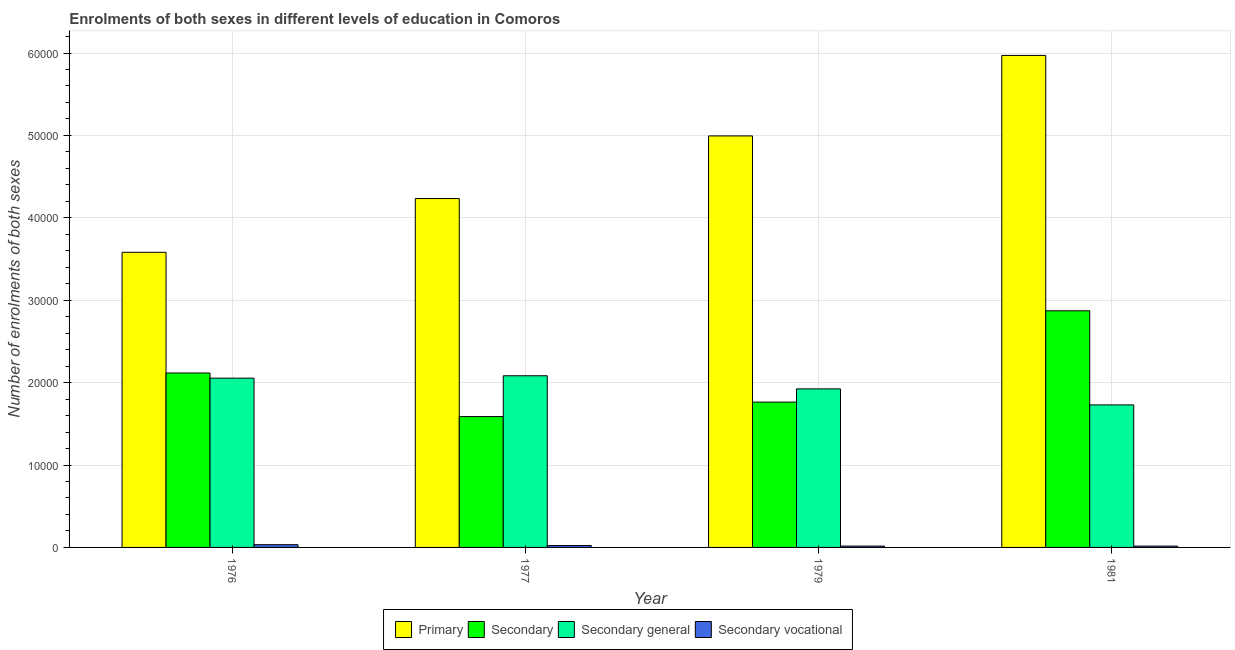Are the number of bars on each tick of the X-axis equal?
Give a very brief answer. Yes. How many bars are there on the 2nd tick from the left?
Make the answer very short. 4. What is the label of the 1st group of bars from the left?
Offer a terse response. 1976. In how many cases, is the number of bars for a given year not equal to the number of legend labels?
Ensure brevity in your answer.  0. What is the number of enrolments in secondary general education in 1976?
Provide a succinct answer. 2.05e+04. Across all years, what is the maximum number of enrolments in secondary education?
Ensure brevity in your answer.  2.87e+04. Across all years, what is the minimum number of enrolments in secondary vocational education?
Your answer should be compact. 159. In which year was the number of enrolments in primary education maximum?
Provide a succinct answer. 1981. What is the total number of enrolments in secondary general education in the graph?
Provide a succinct answer. 7.79e+04. What is the difference between the number of enrolments in secondary general education in 1976 and that in 1977?
Your answer should be compact. -293. What is the difference between the number of enrolments in secondary vocational education in 1979 and the number of enrolments in primary education in 1981?
Provide a short and direct response. 4. What is the average number of enrolments in secondary general education per year?
Provide a short and direct response. 1.95e+04. In the year 1977, what is the difference between the number of enrolments in secondary general education and number of enrolments in primary education?
Give a very brief answer. 0. In how many years, is the number of enrolments in secondary vocational education greater than 56000?
Your response must be concise. 0. What is the ratio of the number of enrolments in secondary general education in 1976 to that in 1979?
Make the answer very short. 1.07. What is the difference between the highest and the second highest number of enrolments in secondary general education?
Provide a short and direct response. 293. What is the difference between the highest and the lowest number of enrolments in secondary vocational education?
Give a very brief answer. 175. Is it the case that in every year, the sum of the number of enrolments in secondary education and number of enrolments in primary education is greater than the sum of number of enrolments in secondary vocational education and number of enrolments in secondary general education?
Keep it short and to the point. Yes. What does the 1st bar from the left in 1976 represents?
Ensure brevity in your answer.  Primary. What does the 1st bar from the right in 1981 represents?
Your answer should be very brief. Secondary vocational. Is it the case that in every year, the sum of the number of enrolments in primary education and number of enrolments in secondary education is greater than the number of enrolments in secondary general education?
Offer a terse response. Yes. How many bars are there?
Give a very brief answer. 16. Are all the bars in the graph horizontal?
Offer a terse response. No. How many years are there in the graph?
Provide a short and direct response. 4. Does the graph contain any zero values?
Your response must be concise. No. What is the title of the graph?
Ensure brevity in your answer.  Enrolments of both sexes in different levels of education in Comoros. Does "Tertiary education" appear as one of the legend labels in the graph?
Your answer should be compact. No. What is the label or title of the Y-axis?
Give a very brief answer. Number of enrolments of both sexes. What is the Number of enrolments of both sexes of Primary in 1976?
Make the answer very short. 3.58e+04. What is the Number of enrolments of both sexes of Secondary in 1976?
Ensure brevity in your answer.  2.12e+04. What is the Number of enrolments of both sexes of Secondary general in 1976?
Provide a succinct answer. 2.05e+04. What is the Number of enrolments of both sexes of Secondary vocational in 1976?
Your answer should be very brief. 334. What is the Number of enrolments of both sexes in Primary in 1977?
Provide a succinct answer. 4.23e+04. What is the Number of enrolments of both sexes in Secondary in 1977?
Make the answer very short. 1.59e+04. What is the Number of enrolments of both sexes in Secondary general in 1977?
Offer a terse response. 2.08e+04. What is the Number of enrolments of both sexes of Secondary vocational in 1977?
Provide a short and direct response. 231. What is the Number of enrolments of both sexes in Primary in 1979?
Your answer should be compact. 4.99e+04. What is the Number of enrolments of both sexes of Secondary in 1979?
Provide a succinct answer. 1.76e+04. What is the Number of enrolments of both sexes in Secondary general in 1979?
Make the answer very short. 1.92e+04. What is the Number of enrolments of both sexes in Secondary vocational in 1979?
Give a very brief answer. 163. What is the Number of enrolments of both sexes in Primary in 1981?
Keep it short and to the point. 5.97e+04. What is the Number of enrolments of both sexes in Secondary in 1981?
Keep it short and to the point. 2.87e+04. What is the Number of enrolments of both sexes in Secondary general in 1981?
Make the answer very short. 1.73e+04. What is the Number of enrolments of both sexes of Secondary vocational in 1981?
Provide a succinct answer. 159. Across all years, what is the maximum Number of enrolments of both sexes of Primary?
Your response must be concise. 5.97e+04. Across all years, what is the maximum Number of enrolments of both sexes in Secondary?
Offer a very short reply. 2.87e+04. Across all years, what is the maximum Number of enrolments of both sexes of Secondary general?
Your answer should be very brief. 2.08e+04. Across all years, what is the maximum Number of enrolments of both sexes of Secondary vocational?
Your answer should be very brief. 334. Across all years, what is the minimum Number of enrolments of both sexes of Primary?
Provide a succinct answer. 3.58e+04. Across all years, what is the minimum Number of enrolments of both sexes of Secondary?
Provide a short and direct response. 1.59e+04. Across all years, what is the minimum Number of enrolments of both sexes of Secondary general?
Your answer should be compact. 1.73e+04. Across all years, what is the minimum Number of enrolments of both sexes in Secondary vocational?
Provide a succinct answer. 159. What is the total Number of enrolments of both sexes in Primary in the graph?
Provide a succinct answer. 1.88e+05. What is the total Number of enrolments of both sexes in Secondary in the graph?
Your answer should be very brief. 8.34e+04. What is the total Number of enrolments of both sexes of Secondary general in the graph?
Ensure brevity in your answer.  7.79e+04. What is the total Number of enrolments of both sexes of Secondary vocational in the graph?
Your answer should be very brief. 887. What is the difference between the Number of enrolments of both sexes of Primary in 1976 and that in 1977?
Provide a short and direct response. -6520. What is the difference between the Number of enrolments of both sexes in Secondary in 1976 and that in 1977?
Ensure brevity in your answer.  5290. What is the difference between the Number of enrolments of both sexes of Secondary general in 1976 and that in 1977?
Your answer should be very brief. -293. What is the difference between the Number of enrolments of both sexes in Secondary vocational in 1976 and that in 1977?
Your answer should be compact. 103. What is the difference between the Number of enrolments of both sexes of Primary in 1976 and that in 1979?
Provide a succinct answer. -1.41e+04. What is the difference between the Number of enrolments of both sexes of Secondary in 1976 and that in 1979?
Ensure brevity in your answer.  3531. What is the difference between the Number of enrolments of both sexes of Secondary general in 1976 and that in 1979?
Provide a succinct answer. 1300. What is the difference between the Number of enrolments of both sexes in Secondary vocational in 1976 and that in 1979?
Provide a succinct answer. 171. What is the difference between the Number of enrolments of both sexes in Primary in 1976 and that in 1981?
Keep it short and to the point. -2.39e+04. What is the difference between the Number of enrolments of both sexes of Secondary in 1976 and that in 1981?
Make the answer very short. -7550. What is the difference between the Number of enrolments of both sexes of Secondary general in 1976 and that in 1981?
Offer a terse response. 3246. What is the difference between the Number of enrolments of both sexes of Secondary vocational in 1976 and that in 1981?
Your answer should be very brief. 175. What is the difference between the Number of enrolments of both sexes in Primary in 1977 and that in 1979?
Make the answer very short. -7602. What is the difference between the Number of enrolments of both sexes of Secondary in 1977 and that in 1979?
Ensure brevity in your answer.  -1759. What is the difference between the Number of enrolments of both sexes of Secondary general in 1977 and that in 1979?
Make the answer very short. 1593. What is the difference between the Number of enrolments of both sexes in Primary in 1977 and that in 1981?
Offer a very short reply. -1.74e+04. What is the difference between the Number of enrolments of both sexes in Secondary in 1977 and that in 1981?
Your answer should be compact. -1.28e+04. What is the difference between the Number of enrolments of both sexes in Secondary general in 1977 and that in 1981?
Make the answer very short. 3539. What is the difference between the Number of enrolments of both sexes in Primary in 1979 and that in 1981?
Give a very brief answer. -9769. What is the difference between the Number of enrolments of both sexes of Secondary in 1979 and that in 1981?
Provide a succinct answer. -1.11e+04. What is the difference between the Number of enrolments of both sexes in Secondary general in 1979 and that in 1981?
Make the answer very short. 1946. What is the difference between the Number of enrolments of both sexes in Secondary vocational in 1979 and that in 1981?
Your answer should be compact. 4. What is the difference between the Number of enrolments of both sexes of Primary in 1976 and the Number of enrolments of both sexes of Secondary in 1977?
Your answer should be compact. 1.99e+04. What is the difference between the Number of enrolments of both sexes in Primary in 1976 and the Number of enrolments of both sexes in Secondary general in 1977?
Give a very brief answer. 1.50e+04. What is the difference between the Number of enrolments of both sexes of Primary in 1976 and the Number of enrolments of both sexes of Secondary vocational in 1977?
Provide a short and direct response. 3.56e+04. What is the difference between the Number of enrolments of both sexes of Secondary in 1976 and the Number of enrolments of both sexes of Secondary general in 1977?
Offer a very short reply. 334. What is the difference between the Number of enrolments of both sexes of Secondary in 1976 and the Number of enrolments of both sexes of Secondary vocational in 1977?
Offer a terse response. 2.09e+04. What is the difference between the Number of enrolments of both sexes in Secondary general in 1976 and the Number of enrolments of both sexes in Secondary vocational in 1977?
Offer a very short reply. 2.03e+04. What is the difference between the Number of enrolments of both sexes in Primary in 1976 and the Number of enrolments of both sexes in Secondary in 1979?
Provide a short and direct response. 1.82e+04. What is the difference between the Number of enrolments of both sexes of Primary in 1976 and the Number of enrolments of both sexes of Secondary general in 1979?
Make the answer very short. 1.66e+04. What is the difference between the Number of enrolments of both sexes in Primary in 1976 and the Number of enrolments of both sexes in Secondary vocational in 1979?
Your response must be concise. 3.57e+04. What is the difference between the Number of enrolments of both sexes of Secondary in 1976 and the Number of enrolments of both sexes of Secondary general in 1979?
Your answer should be compact. 1927. What is the difference between the Number of enrolments of both sexes of Secondary in 1976 and the Number of enrolments of both sexes of Secondary vocational in 1979?
Ensure brevity in your answer.  2.10e+04. What is the difference between the Number of enrolments of both sexes of Secondary general in 1976 and the Number of enrolments of both sexes of Secondary vocational in 1979?
Keep it short and to the point. 2.04e+04. What is the difference between the Number of enrolments of both sexes in Primary in 1976 and the Number of enrolments of both sexes in Secondary in 1981?
Ensure brevity in your answer.  7100. What is the difference between the Number of enrolments of both sexes in Primary in 1976 and the Number of enrolments of both sexes in Secondary general in 1981?
Offer a very short reply. 1.85e+04. What is the difference between the Number of enrolments of both sexes of Primary in 1976 and the Number of enrolments of both sexes of Secondary vocational in 1981?
Make the answer very short. 3.57e+04. What is the difference between the Number of enrolments of both sexes of Secondary in 1976 and the Number of enrolments of both sexes of Secondary general in 1981?
Ensure brevity in your answer.  3873. What is the difference between the Number of enrolments of both sexes of Secondary in 1976 and the Number of enrolments of both sexes of Secondary vocational in 1981?
Provide a succinct answer. 2.10e+04. What is the difference between the Number of enrolments of both sexes of Secondary general in 1976 and the Number of enrolments of both sexes of Secondary vocational in 1981?
Give a very brief answer. 2.04e+04. What is the difference between the Number of enrolments of both sexes in Primary in 1977 and the Number of enrolments of both sexes in Secondary in 1979?
Give a very brief answer. 2.47e+04. What is the difference between the Number of enrolments of both sexes of Primary in 1977 and the Number of enrolments of both sexes of Secondary general in 1979?
Make the answer very short. 2.31e+04. What is the difference between the Number of enrolments of both sexes of Primary in 1977 and the Number of enrolments of both sexes of Secondary vocational in 1979?
Give a very brief answer. 4.22e+04. What is the difference between the Number of enrolments of both sexes of Secondary in 1977 and the Number of enrolments of both sexes of Secondary general in 1979?
Provide a short and direct response. -3363. What is the difference between the Number of enrolments of both sexes of Secondary in 1977 and the Number of enrolments of both sexes of Secondary vocational in 1979?
Give a very brief answer. 1.57e+04. What is the difference between the Number of enrolments of both sexes of Secondary general in 1977 and the Number of enrolments of both sexes of Secondary vocational in 1979?
Give a very brief answer. 2.07e+04. What is the difference between the Number of enrolments of both sexes of Primary in 1977 and the Number of enrolments of both sexes of Secondary in 1981?
Make the answer very short. 1.36e+04. What is the difference between the Number of enrolments of both sexes in Primary in 1977 and the Number of enrolments of both sexes in Secondary general in 1981?
Your answer should be very brief. 2.50e+04. What is the difference between the Number of enrolments of both sexes in Primary in 1977 and the Number of enrolments of both sexes in Secondary vocational in 1981?
Offer a terse response. 4.22e+04. What is the difference between the Number of enrolments of both sexes of Secondary in 1977 and the Number of enrolments of both sexes of Secondary general in 1981?
Ensure brevity in your answer.  -1417. What is the difference between the Number of enrolments of both sexes of Secondary in 1977 and the Number of enrolments of both sexes of Secondary vocational in 1981?
Give a very brief answer. 1.57e+04. What is the difference between the Number of enrolments of both sexes in Secondary general in 1977 and the Number of enrolments of both sexes in Secondary vocational in 1981?
Make the answer very short. 2.07e+04. What is the difference between the Number of enrolments of both sexes of Primary in 1979 and the Number of enrolments of both sexes of Secondary in 1981?
Your answer should be compact. 2.12e+04. What is the difference between the Number of enrolments of both sexes in Primary in 1979 and the Number of enrolments of both sexes in Secondary general in 1981?
Make the answer very short. 3.26e+04. What is the difference between the Number of enrolments of both sexes of Primary in 1979 and the Number of enrolments of both sexes of Secondary vocational in 1981?
Your answer should be compact. 4.98e+04. What is the difference between the Number of enrolments of both sexes of Secondary in 1979 and the Number of enrolments of both sexes of Secondary general in 1981?
Provide a succinct answer. 342. What is the difference between the Number of enrolments of both sexes of Secondary in 1979 and the Number of enrolments of both sexes of Secondary vocational in 1981?
Your answer should be very brief. 1.75e+04. What is the difference between the Number of enrolments of both sexes of Secondary general in 1979 and the Number of enrolments of both sexes of Secondary vocational in 1981?
Offer a terse response. 1.91e+04. What is the average Number of enrolments of both sexes of Primary per year?
Your response must be concise. 4.70e+04. What is the average Number of enrolments of both sexes in Secondary per year?
Keep it short and to the point. 2.09e+04. What is the average Number of enrolments of both sexes of Secondary general per year?
Offer a terse response. 1.95e+04. What is the average Number of enrolments of both sexes in Secondary vocational per year?
Give a very brief answer. 221.75. In the year 1976, what is the difference between the Number of enrolments of both sexes of Primary and Number of enrolments of both sexes of Secondary?
Provide a succinct answer. 1.46e+04. In the year 1976, what is the difference between the Number of enrolments of both sexes in Primary and Number of enrolments of both sexes in Secondary general?
Your answer should be compact. 1.53e+04. In the year 1976, what is the difference between the Number of enrolments of both sexes of Primary and Number of enrolments of both sexes of Secondary vocational?
Offer a very short reply. 3.55e+04. In the year 1976, what is the difference between the Number of enrolments of both sexes in Secondary and Number of enrolments of both sexes in Secondary general?
Offer a terse response. 627. In the year 1976, what is the difference between the Number of enrolments of both sexes of Secondary and Number of enrolments of both sexes of Secondary vocational?
Keep it short and to the point. 2.08e+04. In the year 1976, what is the difference between the Number of enrolments of both sexes of Secondary general and Number of enrolments of both sexes of Secondary vocational?
Give a very brief answer. 2.02e+04. In the year 1977, what is the difference between the Number of enrolments of both sexes of Primary and Number of enrolments of both sexes of Secondary?
Offer a terse response. 2.65e+04. In the year 1977, what is the difference between the Number of enrolments of both sexes of Primary and Number of enrolments of both sexes of Secondary general?
Make the answer very short. 2.15e+04. In the year 1977, what is the difference between the Number of enrolments of both sexes of Primary and Number of enrolments of both sexes of Secondary vocational?
Provide a short and direct response. 4.21e+04. In the year 1977, what is the difference between the Number of enrolments of both sexes of Secondary and Number of enrolments of both sexes of Secondary general?
Provide a short and direct response. -4956. In the year 1977, what is the difference between the Number of enrolments of both sexes of Secondary and Number of enrolments of both sexes of Secondary vocational?
Provide a short and direct response. 1.56e+04. In the year 1977, what is the difference between the Number of enrolments of both sexes in Secondary general and Number of enrolments of both sexes in Secondary vocational?
Your answer should be very brief. 2.06e+04. In the year 1979, what is the difference between the Number of enrolments of both sexes of Primary and Number of enrolments of both sexes of Secondary?
Offer a very short reply. 3.23e+04. In the year 1979, what is the difference between the Number of enrolments of both sexes in Primary and Number of enrolments of both sexes in Secondary general?
Give a very brief answer. 3.07e+04. In the year 1979, what is the difference between the Number of enrolments of both sexes in Primary and Number of enrolments of both sexes in Secondary vocational?
Provide a short and direct response. 4.98e+04. In the year 1979, what is the difference between the Number of enrolments of both sexes in Secondary and Number of enrolments of both sexes in Secondary general?
Your response must be concise. -1604. In the year 1979, what is the difference between the Number of enrolments of both sexes of Secondary and Number of enrolments of both sexes of Secondary vocational?
Offer a very short reply. 1.75e+04. In the year 1979, what is the difference between the Number of enrolments of both sexes in Secondary general and Number of enrolments of both sexes in Secondary vocational?
Offer a very short reply. 1.91e+04. In the year 1981, what is the difference between the Number of enrolments of both sexes in Primary and Number of enrolments of both sexes in Secondary?
Your response must be concise. 3.10e+04. In the year 1981, what is the difference between the Number of enrolments of both sexes in Primary and Number of enrolments of both sexes in Secondary general?
Offer a very short reply. 4.24e+04. In the year 1981, what is the difference between the Number of enrolments of both sexes of Primary and Number of enrolments of both sexes of Secondary vocational?
Keep it short and to the point. 5.96e+04. In the year 1981, what is the difference between the Number of enrolments of both sexes of Secondary and Number of enrolments of both sexes of Secondary general?
Give a very brief answer. 1.14e+04. In the year 1981, what is the difference between the Number of enrolments of both sexes in Secondary and Number of enrolments of both sexes in Secondary vocational?
Your answer should be very brief. 2.86e+04. In the year 1981, what is the difference between the Number of enrolments of both sexes in Secondary general and Number of enrolments of both sexes in Secondary vocational?
Provide a succinct answer. 1.71e+04. What is the ratio of the Number of enrolments of both sexes in Primary in 1976 to that in 1977?
Keep it short and to the point. 0.85. What is the ratio of the Number of enrolments of both sexes in Secondary in 1976 to that in 1977?
Keep it short and to the point. 1.33. What is the ratio of the Number of enrolments of both sexes in Secondary general in 1976 to that in 1977?
Offer a terse response. 0.99. What is the ratio of the Number of enrolments of both sexes of Secondary vocational in 1976 to that in 1977?
Your answer should be compact. 1.45. What is the ratio of the Number of enrolments of both sexes of Primary in 1976 to that in 1979?
Your answer should be compact. 0.72. What is the ratio of the Number of enrolments of both sexes of Secondary in 1976 to that in 1979?
Provide a succinct answer. 1.2. What is the ratio of the Number of enrolments of both sexes of Secondary general in 1976 to that in 1979?
Provide a succinct answer. 1.07. What is the ratio of the Number of enrolments of both sexes of Secondary vocational in 1976 to that in 1979?
Your answer should be compact. 2.05. What is the ratio of the Number of enrolments of both sexes in Primary in 1976 to that in 1981?
Your answer should be very brief. 0.6. What is the ratio of the Number of enrolments of both sexes of Secondary in 1976 to that in 1981?
Your answer should be compact. 0.74. What is the ratio of the Number of enrolments of both sexes of Secondary general in 1976 to that in 1981?
Offer a terse response. 1.19. What is the ratio of the Number of enrolments of both sexes in Secondary vocational in 1976 to that in 1981?
Ensure brevity in your answer.  2.1. What is the ratio of the Number of enrolments of both sexes of Primary in 1977 to that in 1979?
Give a very brief answer. 0.85. What is the ratio of the Number of enrolments of both sexes in Secondary in 1977 to that in 1979?
Your answer should be very brief. 0.9. What is the ratio of the Number of enrolments of both sexes in Secondary general in 1977 to that in 1979?
Your response must be concise. 1.08. What is the ratio of the Number of enrolments of both sexes of Secondary vocational in 1977 to that in 1979?
Offer a very short reply. 1.42. What is the ratio of the Number of enrolments of both sexes in Primary in 1977 to that in 1981?
Your answer should be compact. 0.71. What is the ratio of the Number of enrolments of both sexes of Secondary in 1977 to that in 1981?
Your answer should be compact. 0.55. What is the ratio of the Number of enrolments of both sexes of Secondary general in 1977 to that in 1981?
Ensure brevity in your answer.  1.2. What is the ratio of the Number of enrolments of both sexes of Secondary vocational in 1977 to that in 1981?
Provide a short and direct response. 1.45. What is the ratio of the Number of enrolments of both sexes in Primary in 1979 to that in 1981?
Your answer should be very brief. 0.84. What is the ratio of the Number of enrolments of both sexes in Secondary in 1979 to that in 1981?
Your response must be concise. 0.61. What is the ratio of the Number of enrolments of both sexes of Secondary general in 1979 to that in 1981?
Offer a very short reply. 1.11. What is the ratio of the Number of enrolments of both sexes in Secondary vocational in 1979 to that in 1981?
Offer a terse response. 1.03. What is the difference between the highest and the second highest Number of enrolments of both sexes in Primary?
Your answer should be very brief. 9769. What is the difference between the highest and the second highest Number of enrolments of both sexes in Secondary?
Your response must be concise. 7550. What is the difference between the highest and the second highest Number of enrolments of both sexes in Secondary general?
Offer a very short reply. 293. What is the difference between the highest and the second highest Number of enrolments of both sexes in Secondary vocational?
Your response must be concise. 103. What is the difference between the highest and the lowest Number of enrolments of both sexes in Primary?
Keep it short and to the point. 2.39e+04. What is the difference between the highest and the lowest Number of enrolments of both sexes of Secondary?
Your answer should be very brief. 1.28e+04. What is the difference between the highest and the lowest Number of enrolments of both sexes in Secondary general?
Make the answer very short. 3539. What is the difference between the highest and the lowest Number of enrolments of both sexes of Secondary vocational?
Provide a short and direct response. 175. 